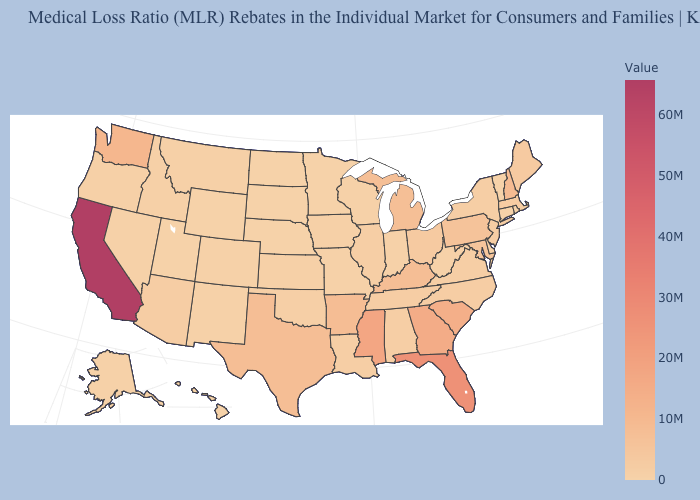Does the map have missing data?
Write a very short answer. No. Among the states that border New Mexico , which have the lowest value?
Keep it brief. Utah. Among the states that border Maryland , does West Virginia have the lowest value?
Short answer required. Yes. Among the states that border Idaho , does Washington have the highest value?
Keep it brief. Yes. Does Minnesota have the lowest value in the MidWest?
Short answer required. Yes. Is the legend a continuous bar?
Write a very short answer. Yes. Among the states that border Massachusetts , does New Hampshire have the highest value?
Quick response, please. Yes. Among the states that border Arkansas , which have the lowest value?
Answer briefly. Missouri. 